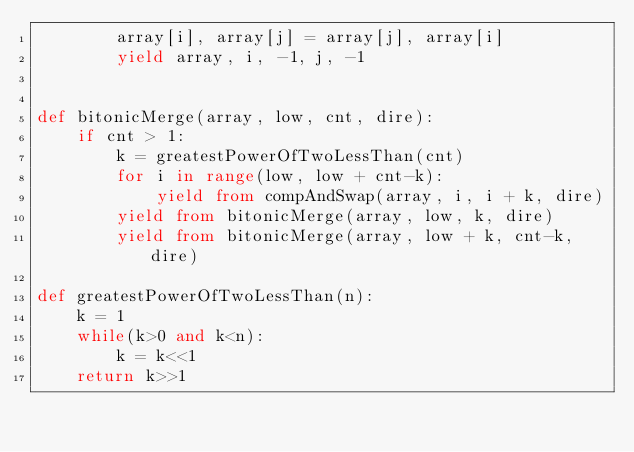<code> <loc_0><loc_0><loc_500><loc_500><_Python_>        array[i], array[j] = array[j], array[i]
        yield array, i, -1, j, -1


def bitonicMerge(array, low, cnt, dire):
    if cnt > 1:
        k = greatestPowerOfTwoLessThan(cnt)
        for i in range(low, low + cnt-k):
            yield from compAndSwap(array, i, i + k, dire)
        yield from bitonicMerge(array, low, k, dire)
        yield from bitonicMerge(array, low + k, cnt-k, dire)

def greatestPowerOfTwoLessThan(n):
    k = 1
    while(k>0 and k<n):
        k = k<<1
    return k>>1
</code> 